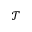<formula> <loc_0><loc_0><loc_500><loc_500>\mathcal { T }</formula> 